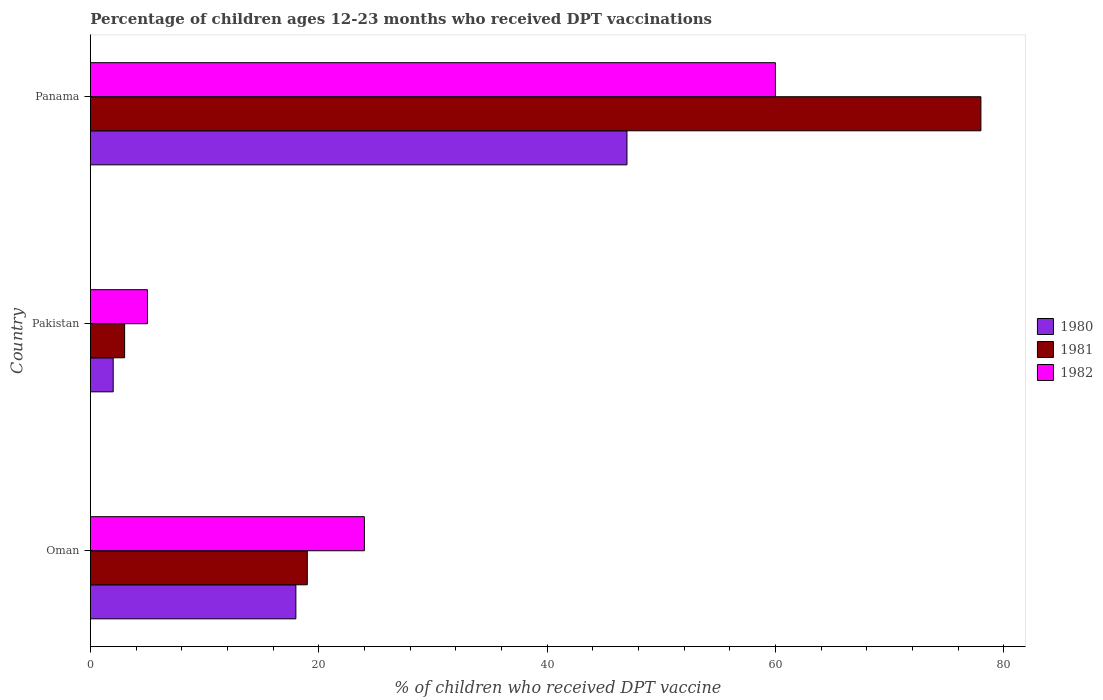How many different coloured bars are there?
Ensure brevity in your answer.  3. How many groups of bars are there?
Your response must be concise. 3. Are the number of bars per tick equal to the number of legend labels?
Your response must be concise. Yes. Are the number of bars on each tick of the Y-axis equal?
Give a very brief answer. Yes. How many bars are there on the 1st tick from the top?
Your answer should be very brief. 3. How many bars are there on the 1st tick from the bottom?
Your response must be concise. 3. What is the label of the 3rd group of bars from the top?
Offer a terse response. Oman. In how many cases, is the number of bars for a given country not equal to the number of legend labels?
Make the answer very short. 0. Across all countries, what is the minimum percentage of children who received DPT vaccination in 1982?
Ensure brevity in your answer.  5. In which country was the percentage of children who received DPT vaccination in 1980 maximum?
Your answer should be very brief. Panama. In which country was the percentage of children who received DPT vaccination in 1980 minimum?
Offer a very short reply. Pakistan. What is the total percentage of children who received DPT vaccination in 1980 in the graph?
Ensure brevity in your answer.  67. What is the difference between the percentage of children who received DPT vaccination in 1982 in Oman and that in Pakistan?
Make the answer very short. 19. What is the average percentage of children who received DPT vaccination in 1982 per country?
Your answer should be very brief. 29.67. In how many countries, is the percentage of children who received DPT vaccination in 1982 greater than 24 %?
Your answer should be compact. 1. What is the ratio of the percentage of children who received DPT vaccination in 1982 in Oman to that in Pakistan?
Your response must be concise. 4.8. Is the difference between the percentage of children who received DPT vaccination in 1981 in Oman and Pakistan greater than the difference between the percentage of children who received DPT vaccination in 1982 in Oman and Pakistan?
Provide a short and direct response. No. What is the difference between the highest and the second highest percentage of children who received DPT vaccination in 1981?
Your response must be concise. 59. What is the difference between the highest and the lowest percentage of children who received DPT vaccination in 1982?
Your response must be concise. 55. What does the 1st bar from the top in Oman represents?
Your answer should be very brief. 1982. Is it the case that in every country, the sum of the percentage of children who received DPT vaccination in 1981 and percentage of children who received DPT vaccination in 1982 is greater than the percentage of children who received DPT vaccination in 1980?
Keep it short and to the point. Yes. How many bars are there?
Offer a very short reply. 9. Does the graph contain any zero values?
Give a very brief answer. No. Does the graph contain grids?
Your response must be concise. No. How many legend labels are there?
Your answer should be very brief. 3. How are the legend labels stacked?
Make the answer very short. Vertical. What is the title of the graph?
Offer a very short reply. Percentage of children ages 12-23 months who received DPT vaccinations. What is the label or title of the X-axis?
Your response must be concise. % of children who received DPT vaccine. What is the label or title of the Y-axis?
Offer a terse response. Country. What is the % of children who received DPT vaccine of 1981 in Oman?
Offer a very short reply. 19. What is the % of children who received DPT vaccine of 1981 in Pakistan?
Your response must be concise. 3. What is the % of children who received DPT vaccine of 1980 in Panama?
Your response must be concise. 47. What is the % of children who received DPT vaccine in 1981 in Panama?
Provide a short and direct response. 78. What is the % of children who received DPT vaccine of 1982 in Panama?
Your answer should be very brief. 60. Across all countries, what is the minimum % of children who received DPT vaccine of 1982?
Keep it short and to the point. 5. What is the total % of children who received DPT vaccine in 1980 in the graph?
Provide a short and direct response. 67. What is the total % of children who received DPT vaccine in 1981 in the graph?
Your answer should be very brief. 100. What is the total % of children who received DPT vaccine of 1982 in the graph?
Keep it short and to the point. 89. What is the difference between the % of children who received DPT vaccine in 1980 in Oman and that in Pakistan?
Keep it short and to the point. 16. What is the difference between the % of children who received DPT vaccine in 1981 in Oman and that in Pakistan?
Give a very brief answer. 16. What is the difference between the % of children who received DPT vaccine of 1981 in Oman and that in Panama?
Your answer should be compact. -59. What is the difference between the % of children who received DPT vaccine of 1982 in Oman and that in Panama?
Provide a succinct answer. -36. What is the difference between the % of children who received DPT vaccine of 1980 in Pakistan and that in Panama?
Keep it short and to the point. -45. What is the difference between the % of children who received DPT vaccine of 1981 in Pakistan and that in Panama?
Provide a succinct answer. -75. What is the difference between the % of children who received DPT vaccine in 1982 in Pakistan and that in Panama?
Offer a terse response. -55. What is the difference between the % of children who received DPT vaccine of 1980 in Oman and the % of children who received DPT vaccine of 1981 in Pakistan?
Your answer should be compact. 15. What is the difference between the % of children who received DPT vaccine in 1980 in Oman and the % of children who received DPT vaccine in 1981 in Panama?
Ensure brevity in your answer.  -60. What is the difference between the % of children who received DPT vaccine in 1980 in Oman and the % of children who received DPT vaccine in 1982 in Panama?
Offer a very short reply. -42. What is the difference between the % of children who received DPT vaccine of 1981 in Oman and the % of children who received DPT vaccine of 1982 in Panama?
Offer a very short reply. -41. What is the difference between the % of children who received DPT vaccine of 1980 in Pakistan and the % of children who received DPT vaccine of 1981 in Panama?
Provide a short and direct response. -76. What is the difference between the % of children who received DPT vaccine in 1980 in Pakistan and the % of children who received DPT vaccine in 1982 in Panama?
Make the answer very short. -58. What is the difference between the % of children who received DPT vaccine in 1981 in Pakistan and the % of children who received DPT vaccine in 1982 in Panama?
Provide a short and direct response. -57. What is the average % of children who received DPT vaccine of 1980 per country?
Offer a very short reply. 22.33. What is the average % of children who received DPT vaccine in 1981 per country?
Offer a very short reply. 33.33. What is the average % of children who received DPT vaccine of 1982 per country?
Make the answer very short. 29.67. What is the difference between the % of children who received DPT vaccine in 1980 and % of children who received DPT vaccine in 1981 in Oman?
Your answer should be very brief. -1. What is the difference between the % of children who received DPT vaccine in 1980 and % of children who received DPT vaccine in 1981 in Pakistan?
Provide a succinct answer. -1. What is the difference between the % of children who received DPT vaccine of 1981 and % of children who received DPT vaccine of 1982 in Pakistan?
Offer a very short reply. -2. What is the difference between the % of children who received DPT vaccine of 1980 and % of children who received DPT vaccine of 1981 in Panama?
Ensure brevity in your answer.  -31. What is the difference between the % of children who received DPT vaccine of 1980 and % of children who received DPT vaccine of 1982 in Panama?
Ensure brevity in your answer.  -13. What is the ratio of the % of children who received DPT vaccine of 1980 in Oman to that in Pakistan?
Your answer should be very brief. 9. What is the ratio of the % of children who received DPT vaccine of 1981 in Oman to that in Pakistan?
Provide a short and direct response. 6.33. What is the ratio of the % of children who received DPT vaccine in 1982 in Oman to that in Pakistan?
Provide a succinct answer. 4.8. What is the ratio of the % of children who received DPT vaccine of 1980 in Oman to that in Panama?
Your response must be concise. 0.38. What is the ratio of the % of children who received DPT vaccine in 1981 in Oman to that in Panama?
Provide a succinct answer. 0.24. What is the ratio of the % of children who received DPT vaccine of 1980 in Pakistan to that in Panama?
Your response must be concise. 0.04. What is the ratio of the % of children who received DPT vaccine of 1981 in Pakistan to that in Panama?
Keep it short and to the point. 0.04. What is the ratio of the % of children who received DPT vaccine in 1982 in Pakistan to that in Panama?
Make the answer very short. 0.08. What is the difference between the highest and the second highest % of children who received DPT vaccine of 1980?
Provide a succinct answer. 29. What is the difference between the highest and the second highest % of children who received DPT vaccine in 1981?
Give a very brief answer. 59. What is the difference between the highest and the second highest % of children who received DPT vaccine of 1982?
Ensure brevity in your answer.  36. What is the difference between the highest and the lowest % of children who received DPT vaccine in 1982?
Offer a terse response. 55. 